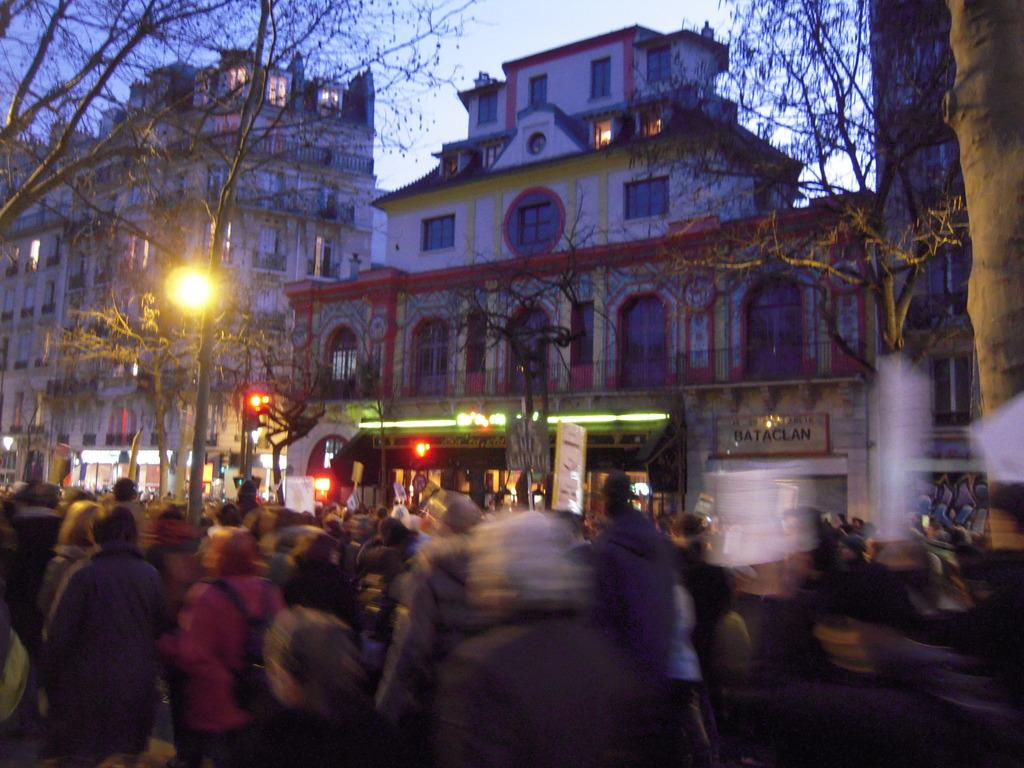Who or what is present in the image? There are people in the image. What can be seen on the left side of the image? There are trees on the left side of the image. What can be seen on the right side of the image? There are trees on the right side of the image. What is visible in the background of the image? There are buildings and the sky visible in the background of the image. Where is the pencil located in the image? There is no pencil present in the image. What type of dock can be seen in the image? There is no dock present in the image. 